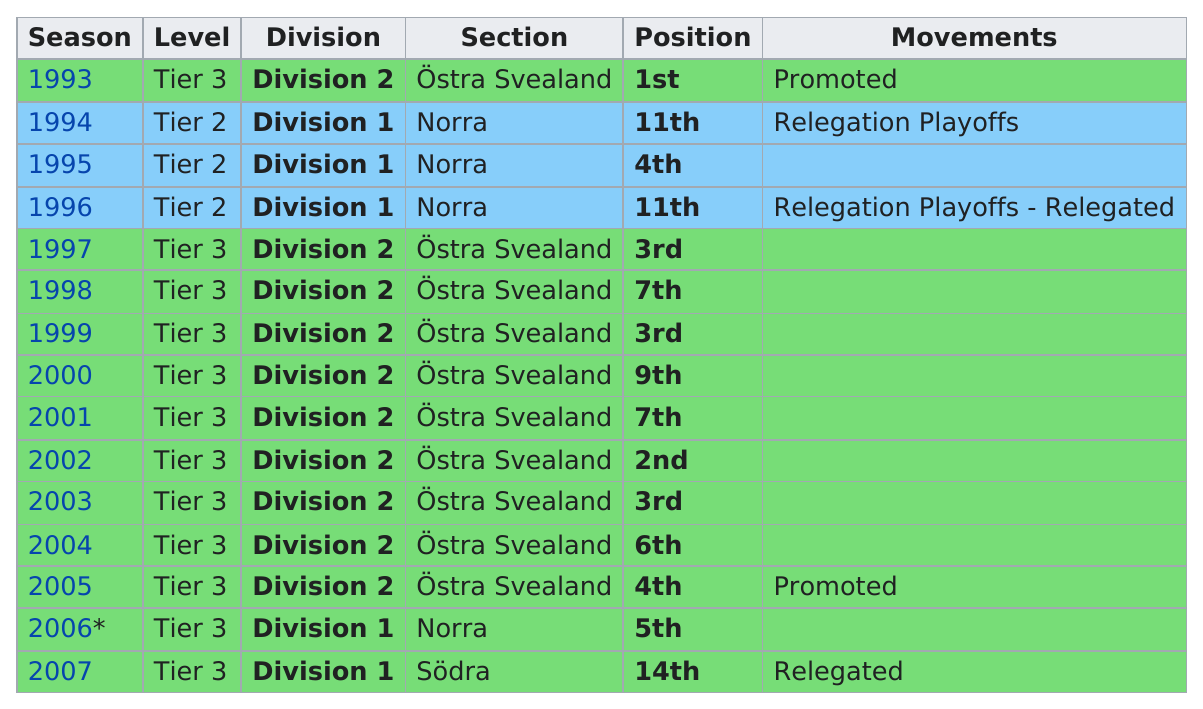Point out several critical features in this image. They finished above 5th place in Division 2 Tier 3 a total of 6 times. The only year that holds the first position is 1993. In 2007, the year was more successful than 2002. In 2000, the team finished ninth in their division, and they performed better the following season. In 2003, they placed third, having previously placed third in 1999. 